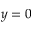<formula> <loc_0><loc_0><loc_500><loc_500>y = 0</formula> 